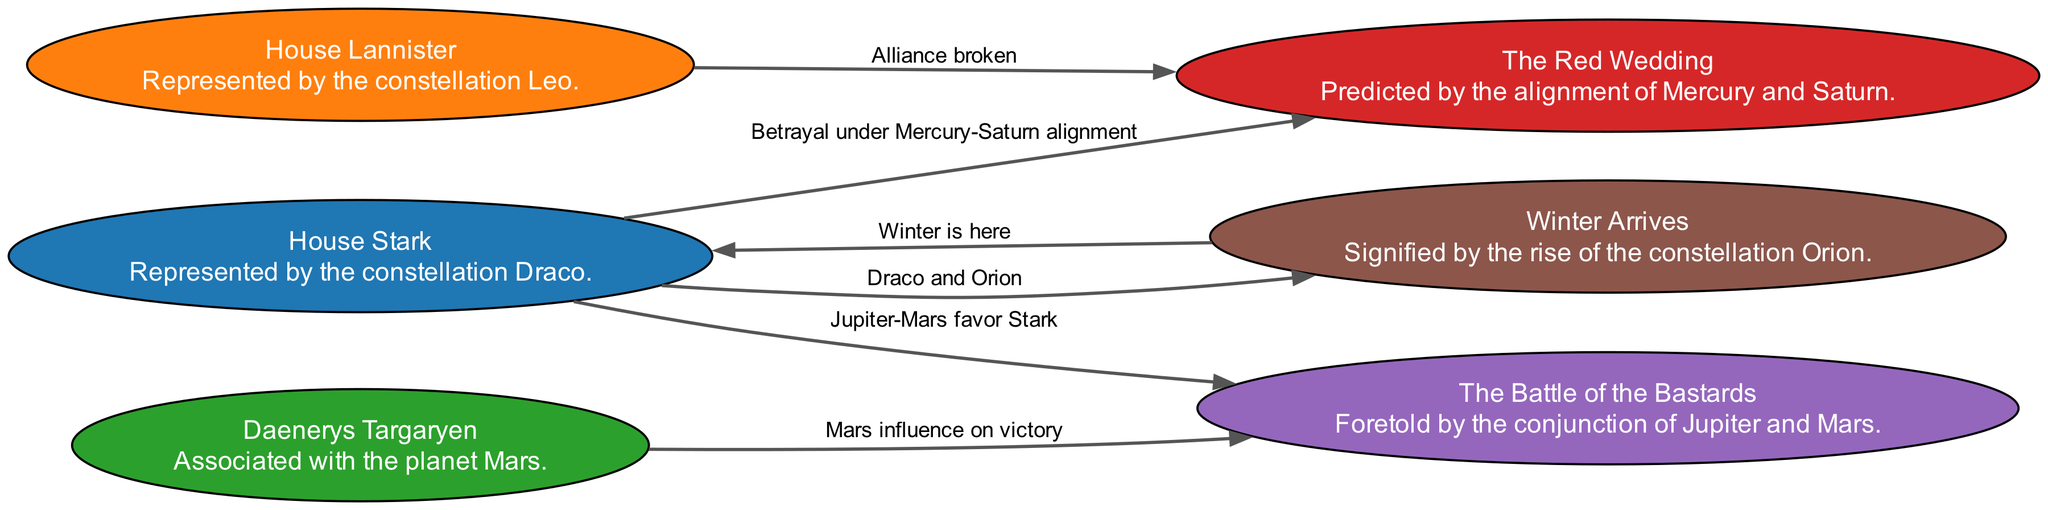What is the representation of House Stark? House Stark is represented by the constellation Draco, as indicated in the diagram description for the node associated with House Stark.
Answer: Draco Which event is predicted by the alignment of Mercury and Saturn? The event predicted by the alignment of Mercury and Saturn is "The Red Wedding," as mentioned in the node description that specifically states this alignment's significance.
Answer: The Red Wedding How many nodes are in the diagram? Counting the nodes listed in the data, there are a total of six nodes each representing a house or event related to the series.
Answer: 6 What does the conjunction of Jupiter and Mars foretell? The conjunction of Jupiter and Mars foretells "The Battle of the Bastards," as explicitly described in the node associated with this event.
Answer: The Battle of the Bastards Which house is linked to the event "Winter Arrives"? The house linked to the event "Winter Arrives" is House Stark, as shown by the connecting edge in the diagram from House Stark to the "Winter Arrives" event.
Answer: House Stark What celestial feature is associated with Daenerys Targaryen? Daenerys Targaryen is associated with the planet Mars, as indicated in her respective node description in the diagram.
Answer: Mars How is betrayal under the Mercury-Saturn alignment characterized in the diagram? Betrayal under the Mercury-Saturn alignment is characterized by an edge leading from House Stark to "The Red Wedding," indicating a dramatic plot twist involving betrayal during this alignment.
Answer: Betrayal under Mercury-Saturn alignment What does the alignment of Draco and Orion signify? The alignment of Draco and Orion signifies the arrival of winter, as represented by the edge connecting House Stark to the event "Winter Arrives."
Answer: Winter Arrives What planetary influence contributes to Stark's favor in battle? Jupiter-Mars favors Stark in battle, specifically in the context of "The Battle of the Bastards," as mentioned in the edge description connecting House Stark and this battle event.
Answer: Jupiter-Mars favor Stark 